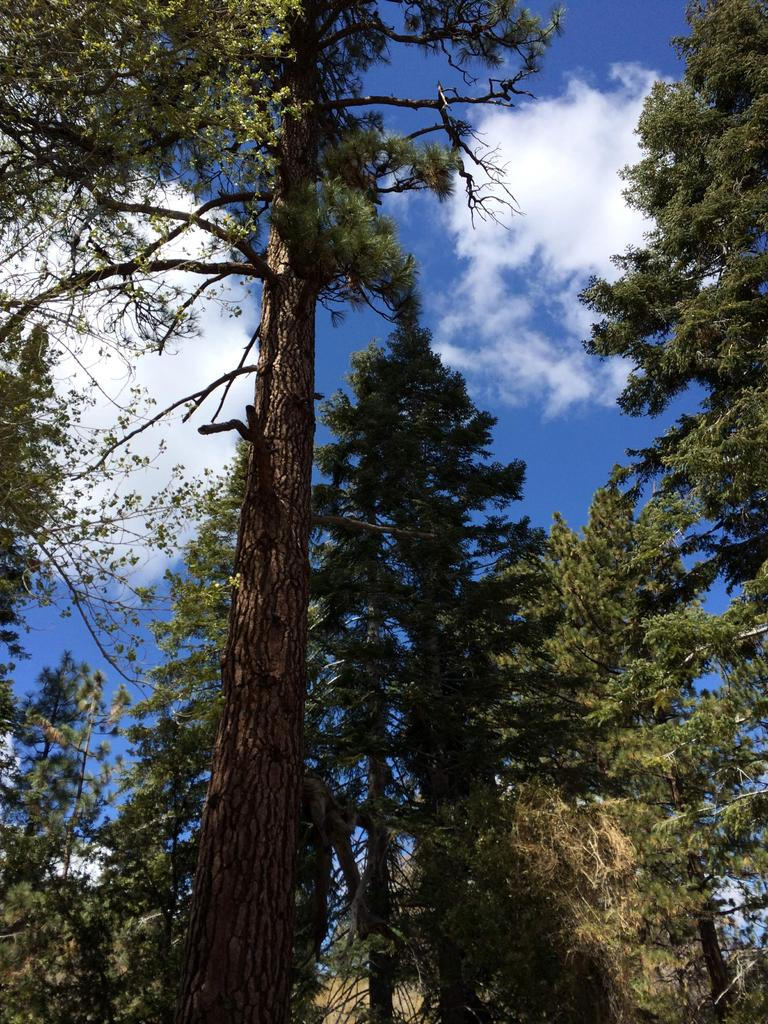What type of natural vegetation can be seen in the image? There are trees in the image. What can be seen in the sky in the image? There are clouds visible in the sky in the image. What type of secretary is visible in the image? There is no secretary present in the image. What is the size of the zipper on the trees in the image? There are no zippers present on the trees in the image. 